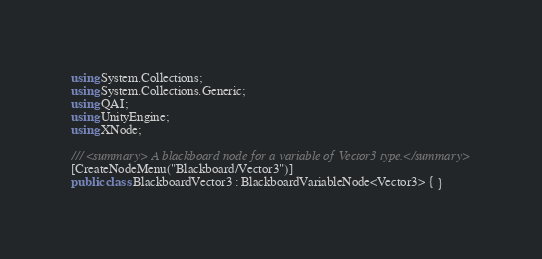<code> <loc_0><loc_0><loc_500><loc_500><_C#_>using System.Collections;
using System.Collections.Generic;
using QAI;
using UnityEngine;
using XNode;

/// <summary> A blackboard node for a variable of Vector3 type.</summary>
[CreateNodeMenu("Blackboard/Vector3")]
public class BlackboardVector3 : BlackboardVariableNode<Vector3> { }</code> 